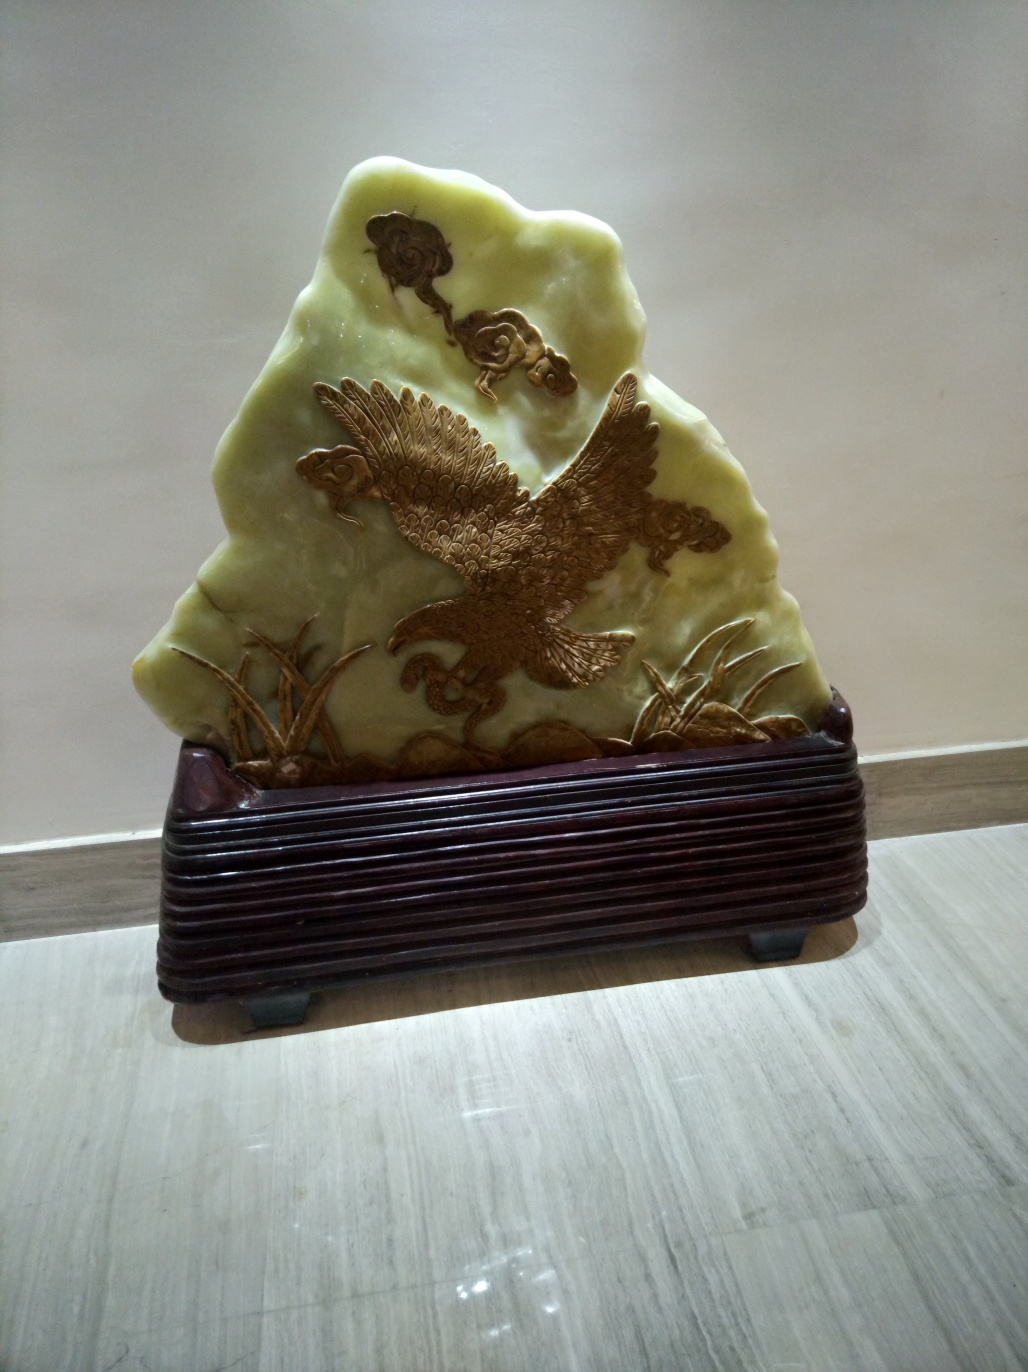Is this item likely to be used for practical purposes, or is it purely decorative? The intricacy and delicate nature of the carving suggest that this item is purely decorative. It is likely meant to serve as an ornament or a collector's piece rather than an object for everyday use, as its design focuses on aesthetic appeal and craftsmanship. 